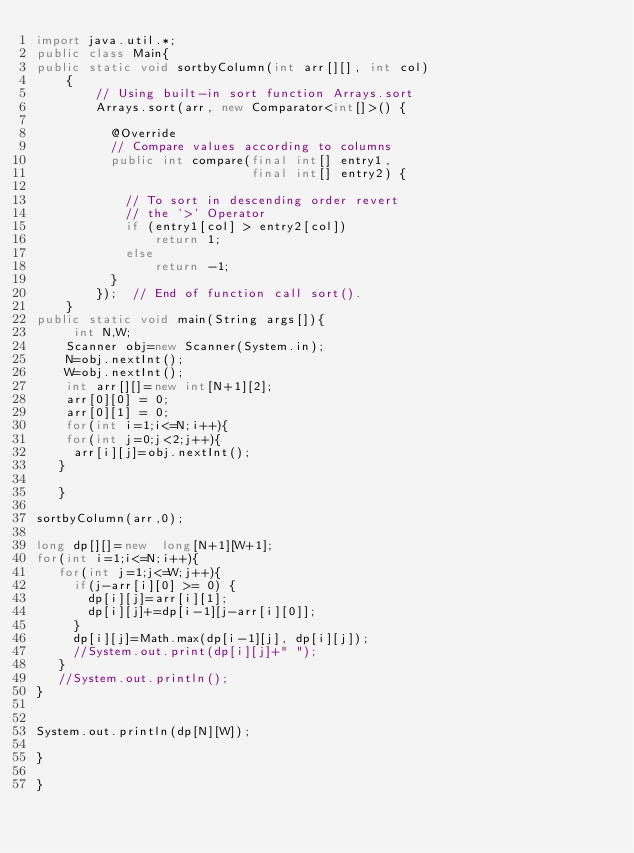<code> <loc_0><loc_0><loc_500><loc_500><_Java_>import java.util.*;
public class Main{
public static void sortbyColumn(int arr[][], int col) 
    { 
        // Using built-in sort function Arrays.sort 
        Arrays.sort(arr, new Comparator<int[]>() { 
            
          @Override              
          // Compare values according to columns 
          public int compare(final int[] entry1,  
                             final int[] entry2) { 
  
            // To sort in descending order revert  
            // the '>' Operator 
            if (entry1[col] > entry2[col]) 
                return 1; 
            else
                return -1; 
          } 
        });  // End of function call sort(). 
    } 
public static void main(String args[]){
     int N,W;
    Scanner obj=new Scanner(System.in);
    N=obj.nextInt();
    W=obj.nextInt();
    int arr[][]=new int[N+1][2];
    arr[0][0] = 0;
    arr[0][1] = 0;
    for(int i=1;i<=N;i++){
    for(int j=0;j<2;j++){
     arr[i][j]=obj.nextInt();
   }
   
   }

sortbyColumn(arr,0);

long dp[][]=new  long[N+1][W+1];
for(int i=1;i<=N;i++){
   for(int j=1;j<=W;j++){
     if(j-arr[i][0] >= 0) {
    	 dp[i][j]=arr[i][1];
    	 dp[i][j]+=dp[i-1][j-arr[i][0]];
     }
     dp[i][j]=Math.max(dp[i-1][j], dp[i][j]);
     //System.out.print(dp[i][j]+" ");
   }
   //System.out.println();
}


System.out.println(dp[N][W]);
 
}

}
</code> 